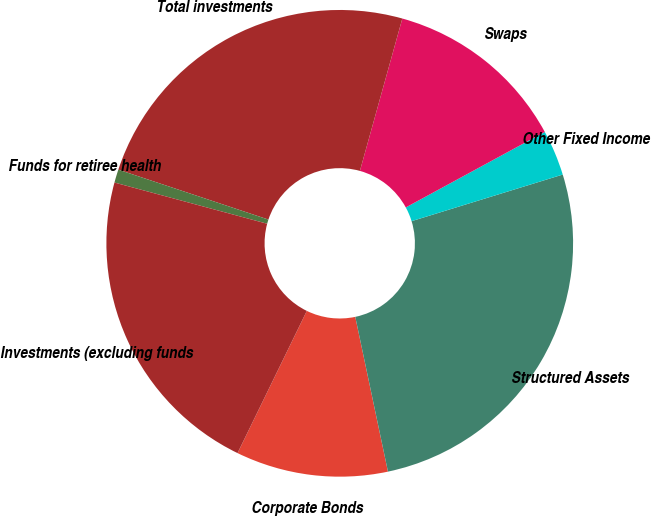Convert chart to OTSL. <chart><loc_0><loc_0><loc_500><loc_500><pie_chart><fcel>Corporate Bonds<fcel>Structured Assets<fcel>Other Fixed Income<fcel>Swaps<fcel>Total investments<fcel>Funds for retiree health<fcel>Investments (excluding funds<nl><fcel>10.53%<fcel>26.45%<fcel>3.16%<fcel>12.76%<fcel>24.21%<fcel>0.92%<fcel>21.98%<nl></chart> 